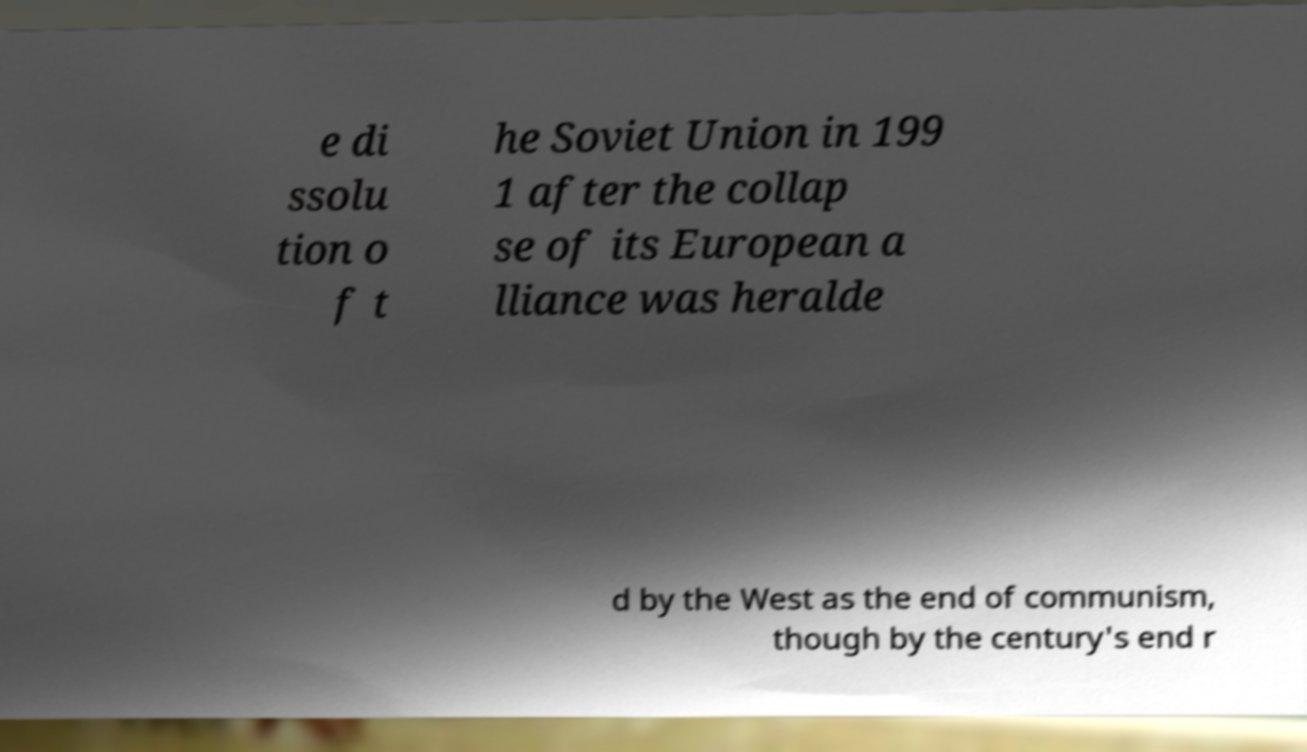What messages or text are displayed in this image? I need them in a readable, typed format. e di ssolu tion o f t he Soviet Union in 199 1 after the collap se of its European a lliance was heralde d by the West as the end of communism, though by the century's end r 